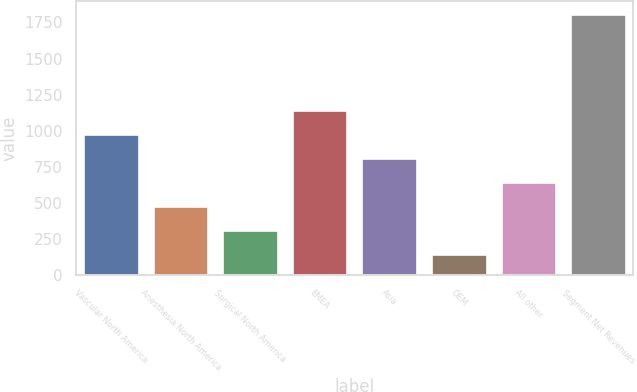<chart> <loc_0><loc_0><loc_500><loc_500><bar_chart><fcel>Vascular North America<fcel>Anesthesia North America<fcel>Surgical North America<fcel>EMEA<fcel>Asia<fcel>OEM<fcel>All other<fcel>Segment Net Revenues<nl><fcel>979.55<fcel>481.46<fcel>315.43<fcel>1145.58<fcel>813.52<fcel>149.4<fcel>647.49<fcel>1809.7<nl></chart> 